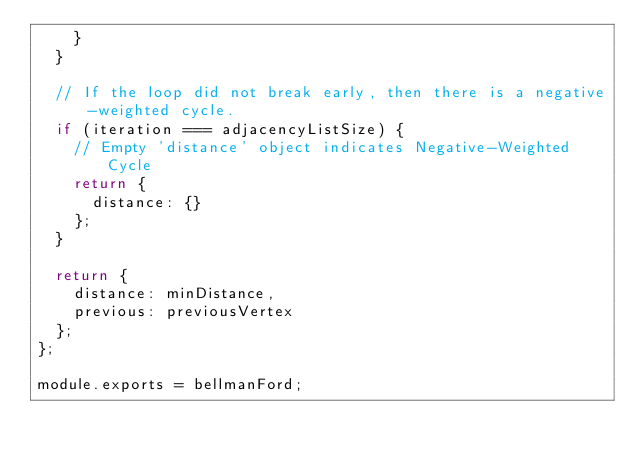<code> <loc_0><loc_0><loc_500><loc_500><_JavaScript_>    }
  }

  // If the loop did not break early, then there is a negative-weighted cycle.
  if (iteration === adjacencyListSize) {
    // Empty 'distance' object indicates Negative-Weighted Cycle
    return {
      distance: {}
    };
  }

  return {
    distance: minDistance,
    previous: previousVertex
  };
};

module.exports = bellmanFord;
</code> 